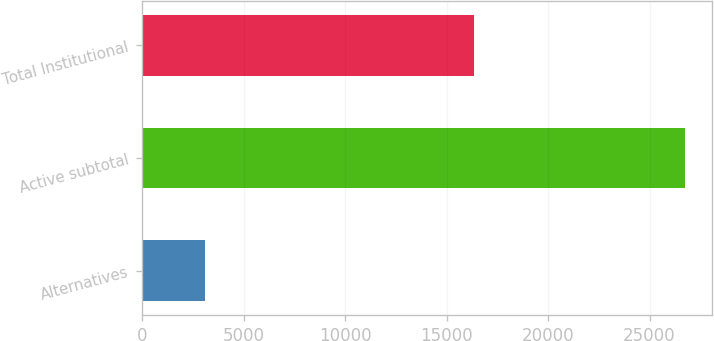Convert chart. <chart><loc_0><loc_0><loc_500><loc_500><bar_chart><fcel>Alternatives<fcel>Active subtotal<fcel>Total Institutional<nl><fcel>3109<fcel>26746<fcel>16350<nl></chart> 